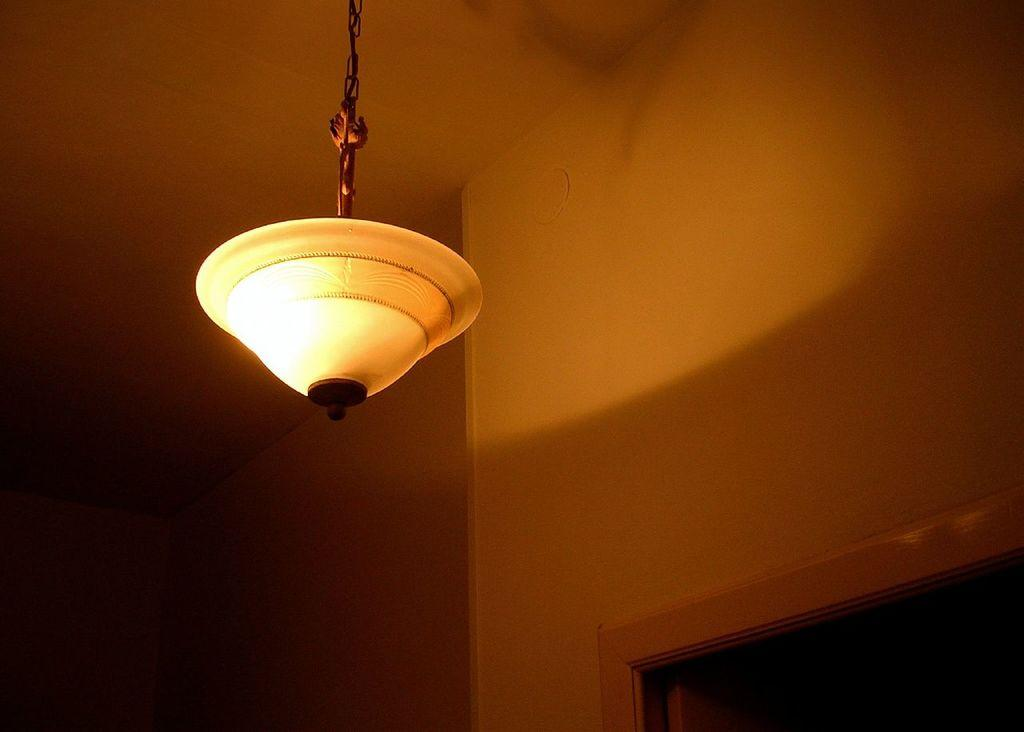What is hanging from the roof in the center of the image? There is a light hanging from the roof in the center of the image. What can be seen in the background of the image? There is a wall and a door in the background of the image. How many legs does the prose have in the image? There is no prose present in the image, and therefore no legs can be counted. 